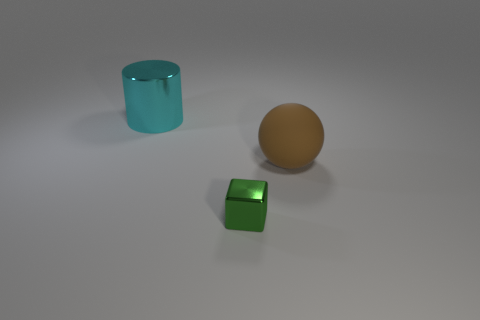How does the size of the teal cylinder compare to the other objects in the image? The teal cylinder is medium-sized when compared to the other objects. It's larger than the small green metallic cube but smaller than the large brown sphere. 